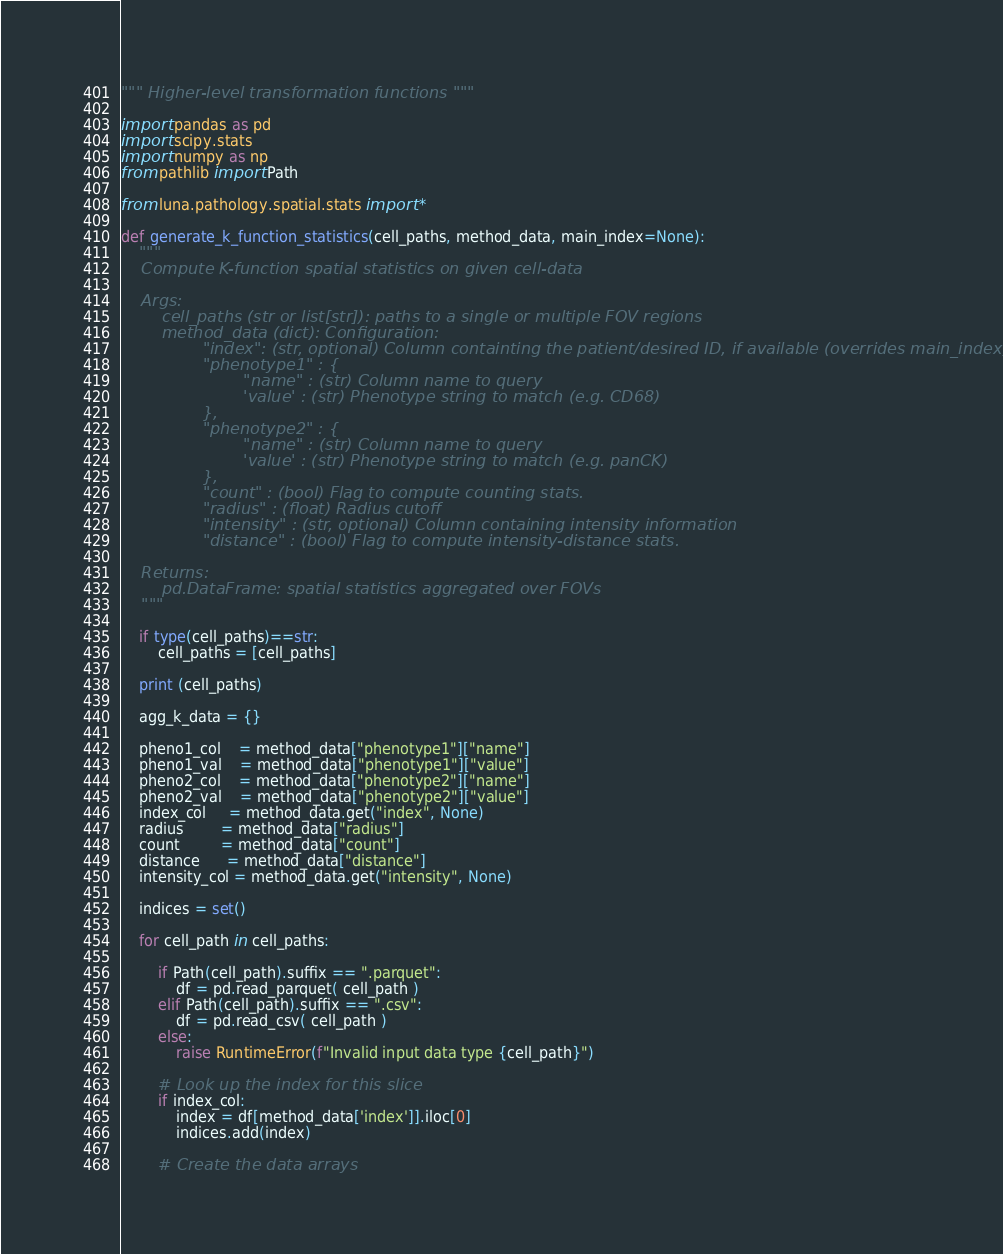<code> <loc_0><loc_0><loc_500><loc_500><_Python_>""" Higher-level transformation functions """

import pandas as pd
import scipy.stats
import numpy as np
from pathlib import Path

from luna.pathology.spatial.stats import *

def generate_k_function_statistics(cell_paths, method_data, main_index=None):
    """
    Compute K-function spatial statistics on given cell-data

    Args:
        cell_paths (str or list[str]): paths to a single or multiple FOV regions
        method_data (dict): Configuration:
                "index": (str, optional) Column containting the patient/desired ID, if available (overrides main_index)
                "phenotype1" : {
                        "name" : (str) Column name to query
                        'value' : (str) Phenotype string to match (e.g. CD68)
                },
                "phenotype2" : {
                        "name" : (str) Column name to query
                        'value' : (str) Phenotype string to match (e.g. panCK)
                },
                "count" : (bool) Flag to compute counting stats.
                "radius" : (float) Radius cutoff
                "intensity" : (str, optional) Column containing intensity information 
                "distance" : (bool) Flag to compute intensity-distance stats.
    
    Returns:
        pd.DataFrame: spatial statistics aggregated over FOVs
    """

    if type(cell_paths)==str:
        cell_paths = [cell_paths]

    print (cell_paths)

    agg_k_data = {}

    pheno1_col    = method_data["phenotype1"]["name"]
    pheno1_val    = method_data["phenotype1"]["value"]
    pheno2_col    = method_data["phenotype2"]["name"]
    pheno2_val    = method_data["phenotype2"]["value"]
    index_col     = method_data.get("index", None)
    radius        = method_data["radius"]
    count         = method_data["count"]
    distance      = method_data["distance"]
    intensity_col = method_data.get("intensity", None)

    indices = set()

    for cell_path in cell_paths:

        if Path(cell_path).suffix == ".parquet":
            df = pd.read_parquet( cell_path ) 
        elif Path(cell_path).suffix == ".csv":
            df = pd.read_csv( cell_path ) 
        else:
            raise RuntimeError(f"Invalid input data type {cell_path}")

        # Look up the index for this slice
        if index_col:
            index = df[method_data['index']].iloc[0]
            indices.add(index)

        # Create the data arrays</code> 